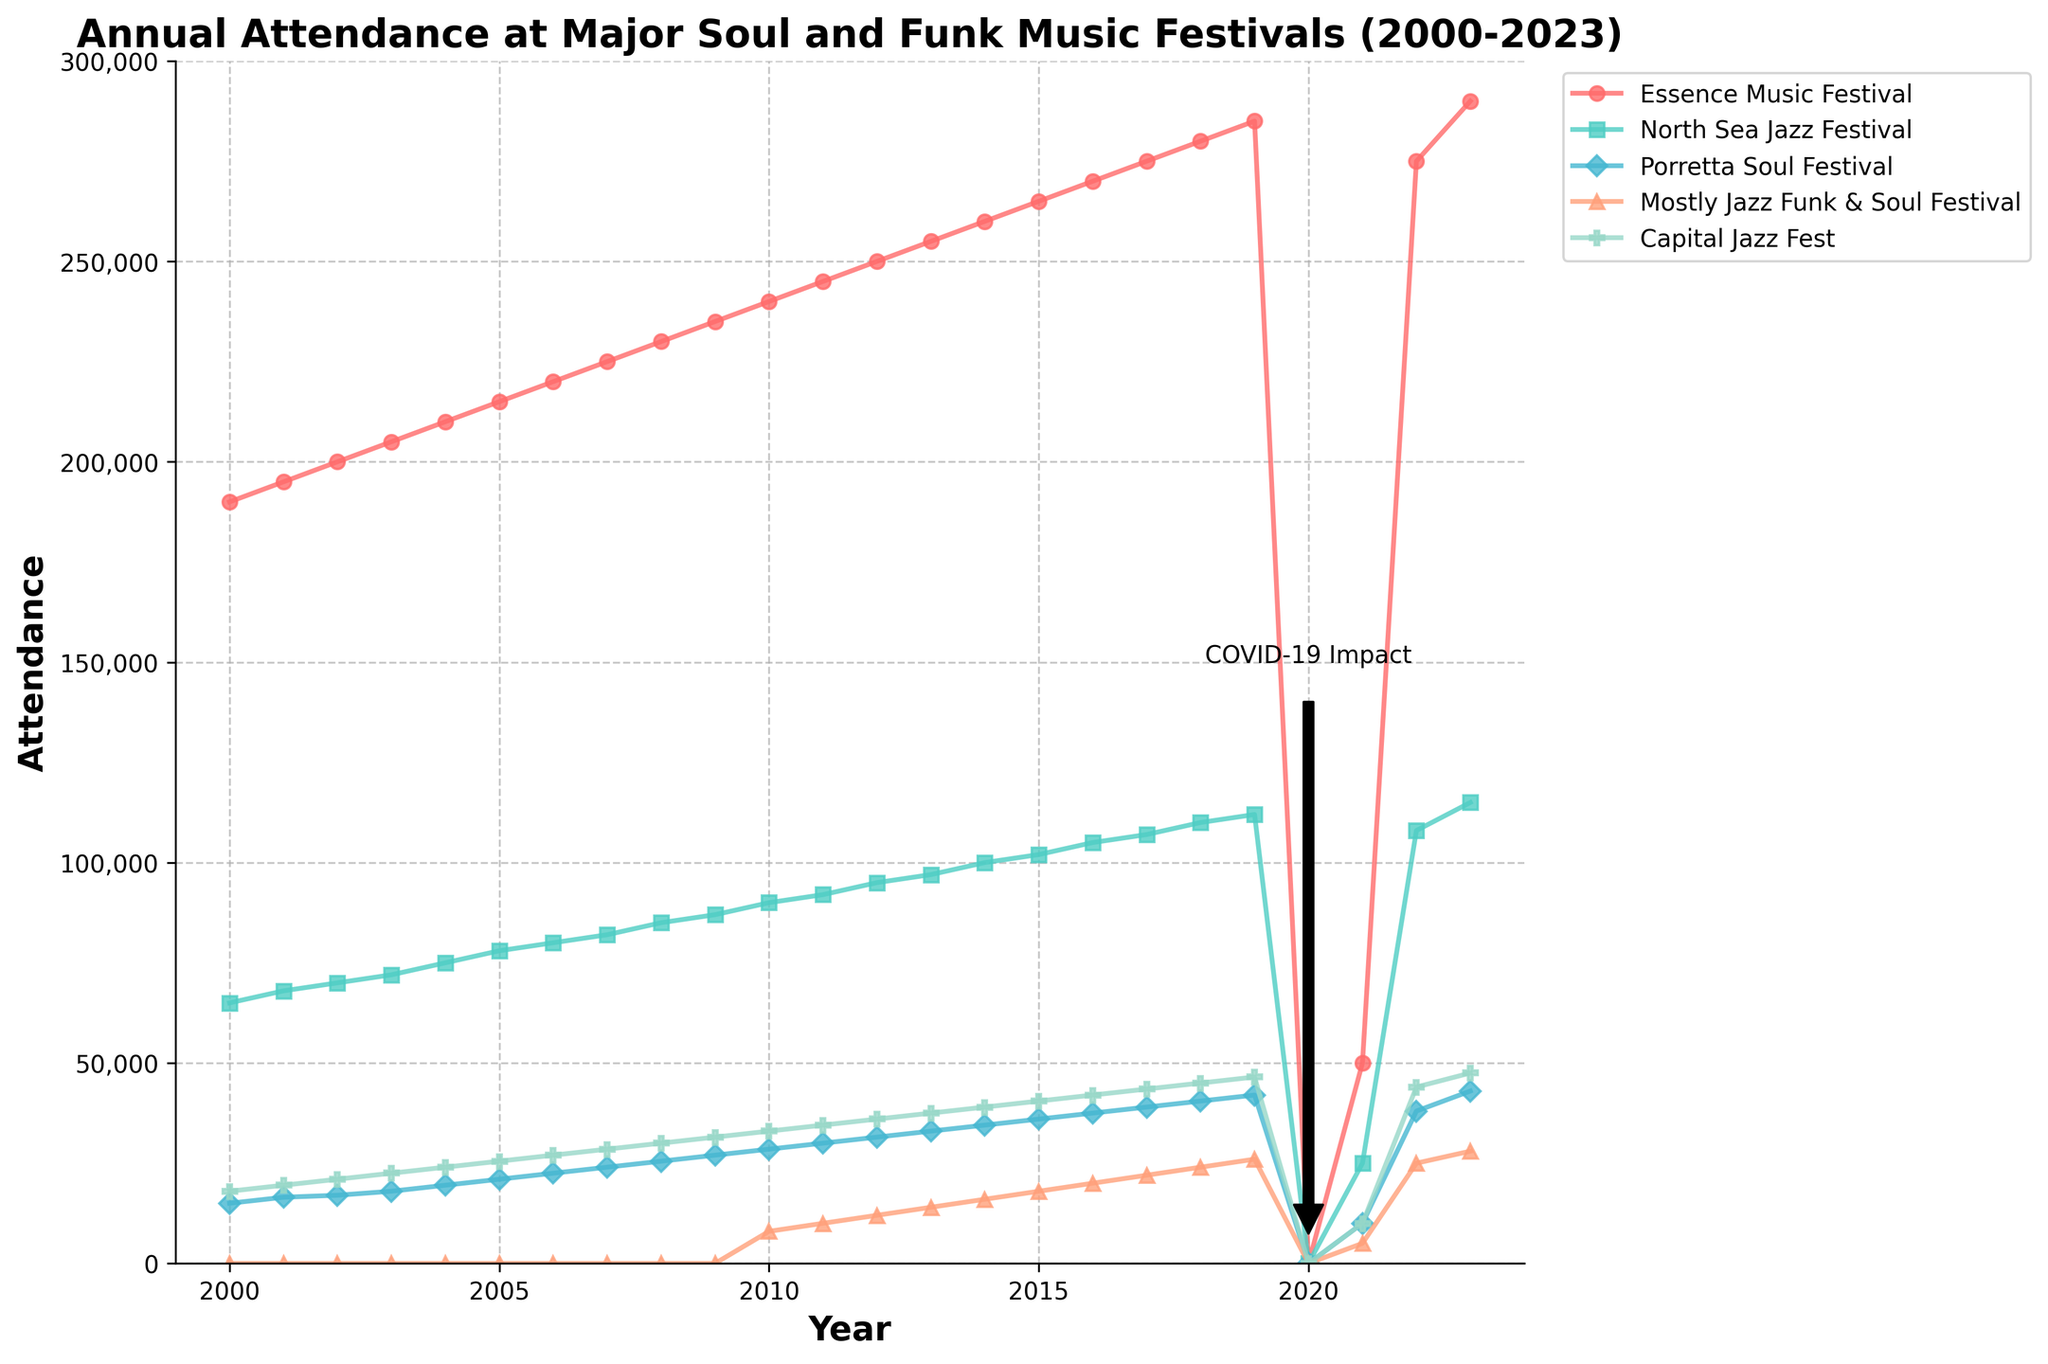what is the total attendance for the year 2023 across all festivals? Add the attendance for each festival in 2023: Essence Music Festival (290,000) + North Sea Jazz Festival (115,000) + Porretta Soul Festival (43,000) + Mostly Jazz Funk & Soul Festival (28,000) + Capital Jazz Fest (47,500). The sum is 290,000 + 115,000 + 43,000 + 28,000 + 47,500 = 523,500
Answer: 523,500 how does the attendance at the North Sea Jazz Festival in 2023 compare to its attendance in 2022? Attendance at North Sea Jazz Festival in 2023 is 115,000 and in 2022 it was 108,000. Comparing the two, 115,000 is greater than 108,000. The difference is 115,000 - 108,000 = 7,000
Answer: The attendance increased by 7,000 from 2022 to 2023 which festival had the highest attendance drop between 2019 and 2020? Check the attendance in 2019 and 2020 for each festival. Attendance in 2020 for all festivals is zero due to COVID-19. The attendance drop is the same for each festival and equals their 2019 attendance: Essence Music Festival (285,000), North Sea Jazz Festival (112,000), Porretta Soul Festival (42,000), Mostly Jazz Funk & Soul Festival (26,000), Capital Jazz Fest (46,500). The highest drop is 285,000 for Essence Music Festival
Answer: Essence Music Festival what is the average annual attendance at the Essence Music Festival from 2000 to 2023, excluding 2020? Sum the attendance across all years from 2000 to 2023, excluding 2020 where attendance is zero. The total sum is 190,000 + 195,000 + 200,000 + 205,000 + 210,000 + 215,000 + 220,000 + 225,000 + 230,000 + 235,000 + 240,000 + 245,000 + 250,000 + 255,000 + 260,000 + 265,000 + 270,000 + 275,000 + 280,000 + 285,000 + 50,000 + 275,000 + 290,000. This total is 5,695,000. Divide by the number of years excluding 2020 (23 years) to find the average: 5,695,000 / 23 = 247,609
Answer: 247,609 which festival shows the most consistent annual growth in attendance from 2000 to 2023? Check the trend lines of each festival from 2000 to 2023. The Essence Music Festival shows a steady and consistent increase in attendance almost every year, except for the impact year of 2020 and 2021. While other festivals show variations or periods of no data, the Essence Music Festival’s growth line is smoother and consistently upward
Answer: Essence Music Festival in which year did the Mostly Jazz Funk & Soul Festival start to report attendance figures? Check the plot to find the first year with a non-zero attendance for the Mostly Jazz Funk & Soul Festival. The first non-zero attendance occurs in 2010
Answer: 2010 compare the total attendance at all festivals in 2019 to the total attendance in 2023. Total attendance in 2019: Essence Music Festival (285,000) + North Sea Jazz Festival (112,000) + Porretta Soul Festival (42,000) + Mostly Jazz Funk & Soul Festival (26,000) + Capital Jazz Fest (46,500) = 511,500. Total attendance in 2023: Essence Music Festival (290,000) + North Sea Jazz Festival (115,000) + Porretta Soul Festival (43,000) + Mostly Jazz Funk & Soul Festival (28,000) + Capital Jazz Fest (47,500) = 523,500. The difference is 523,500 - 511,500 = 12,000
Answer: 12,000 more in 2023 than in 2019 